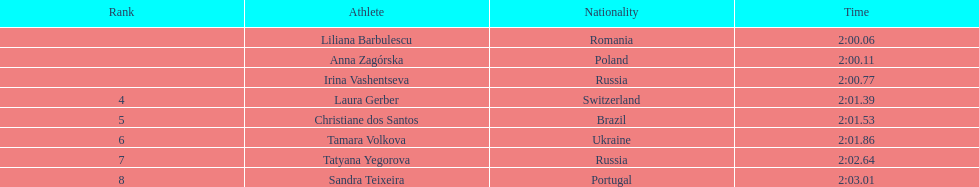Which south american country placed after irina vashentseva? Brazil. 